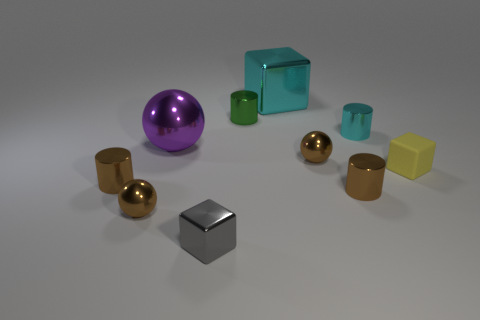How many brown balls must be subtracted to get 1 brown balls? 1 Subtract all blocks. How many objects are left? 7 Subtract 1 blocks. How many blocks are left? 2 Subtract all brown balls. Subtract all brown cubes. How many balls are left? 1 Subtract all yellow balls. How many yellow blocks are left? 1 Subtract all large purple shiny objects. Subtract all big cyan blocks. How many objects are left? 8 Add 5 tiny cyan shiny objects. How many tiny cyan shiny objects are left? 6 Add 2 purple things. How many purple things exist? 3 Subtract all purple balls. How many balls are left? 2 Subtract all large shiny blocks. How many blocks are left? 2 